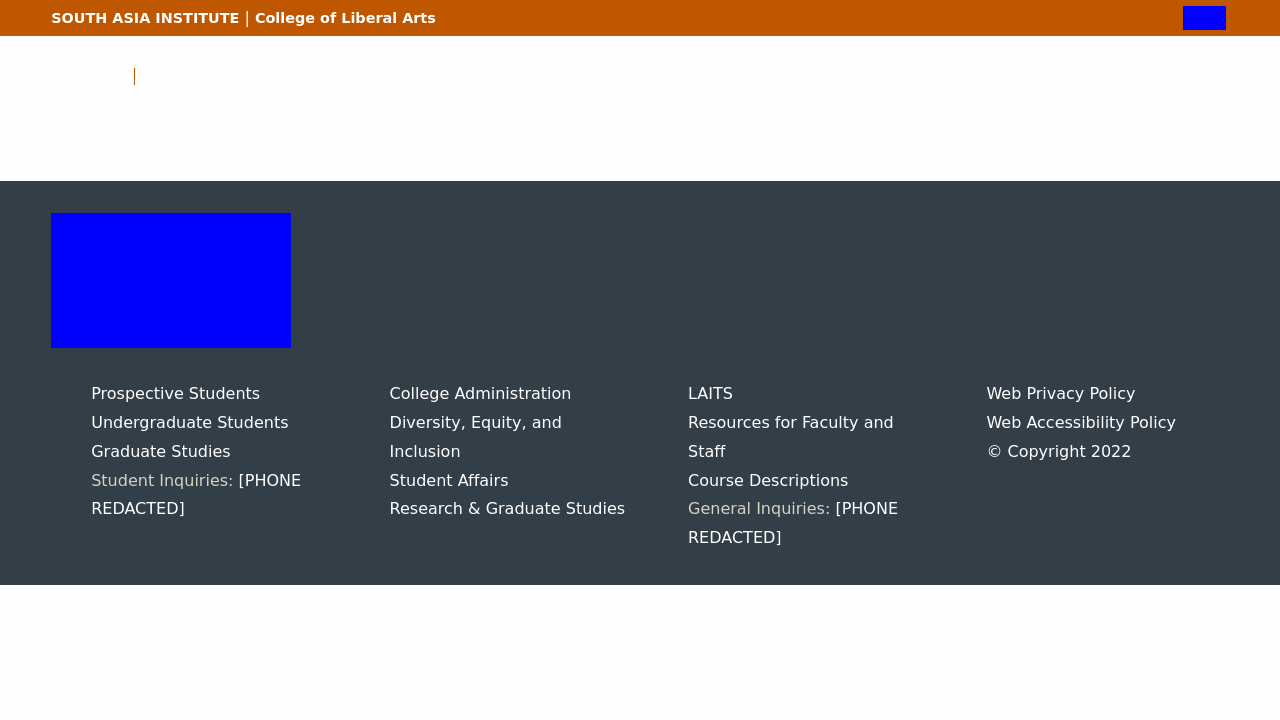Can you describe the structure of the sidebar shown in the image related to university services? The sidebar in the image functions as a menu for different university services such as Administration, Diversity policies, and Student Affairs. Each section is likely anchored by hyperlinks facilitating easy navigation to detailed pages on each topic. It uses a minimalist design likely to keep the focus on accessibility and ease of information retrieval. 